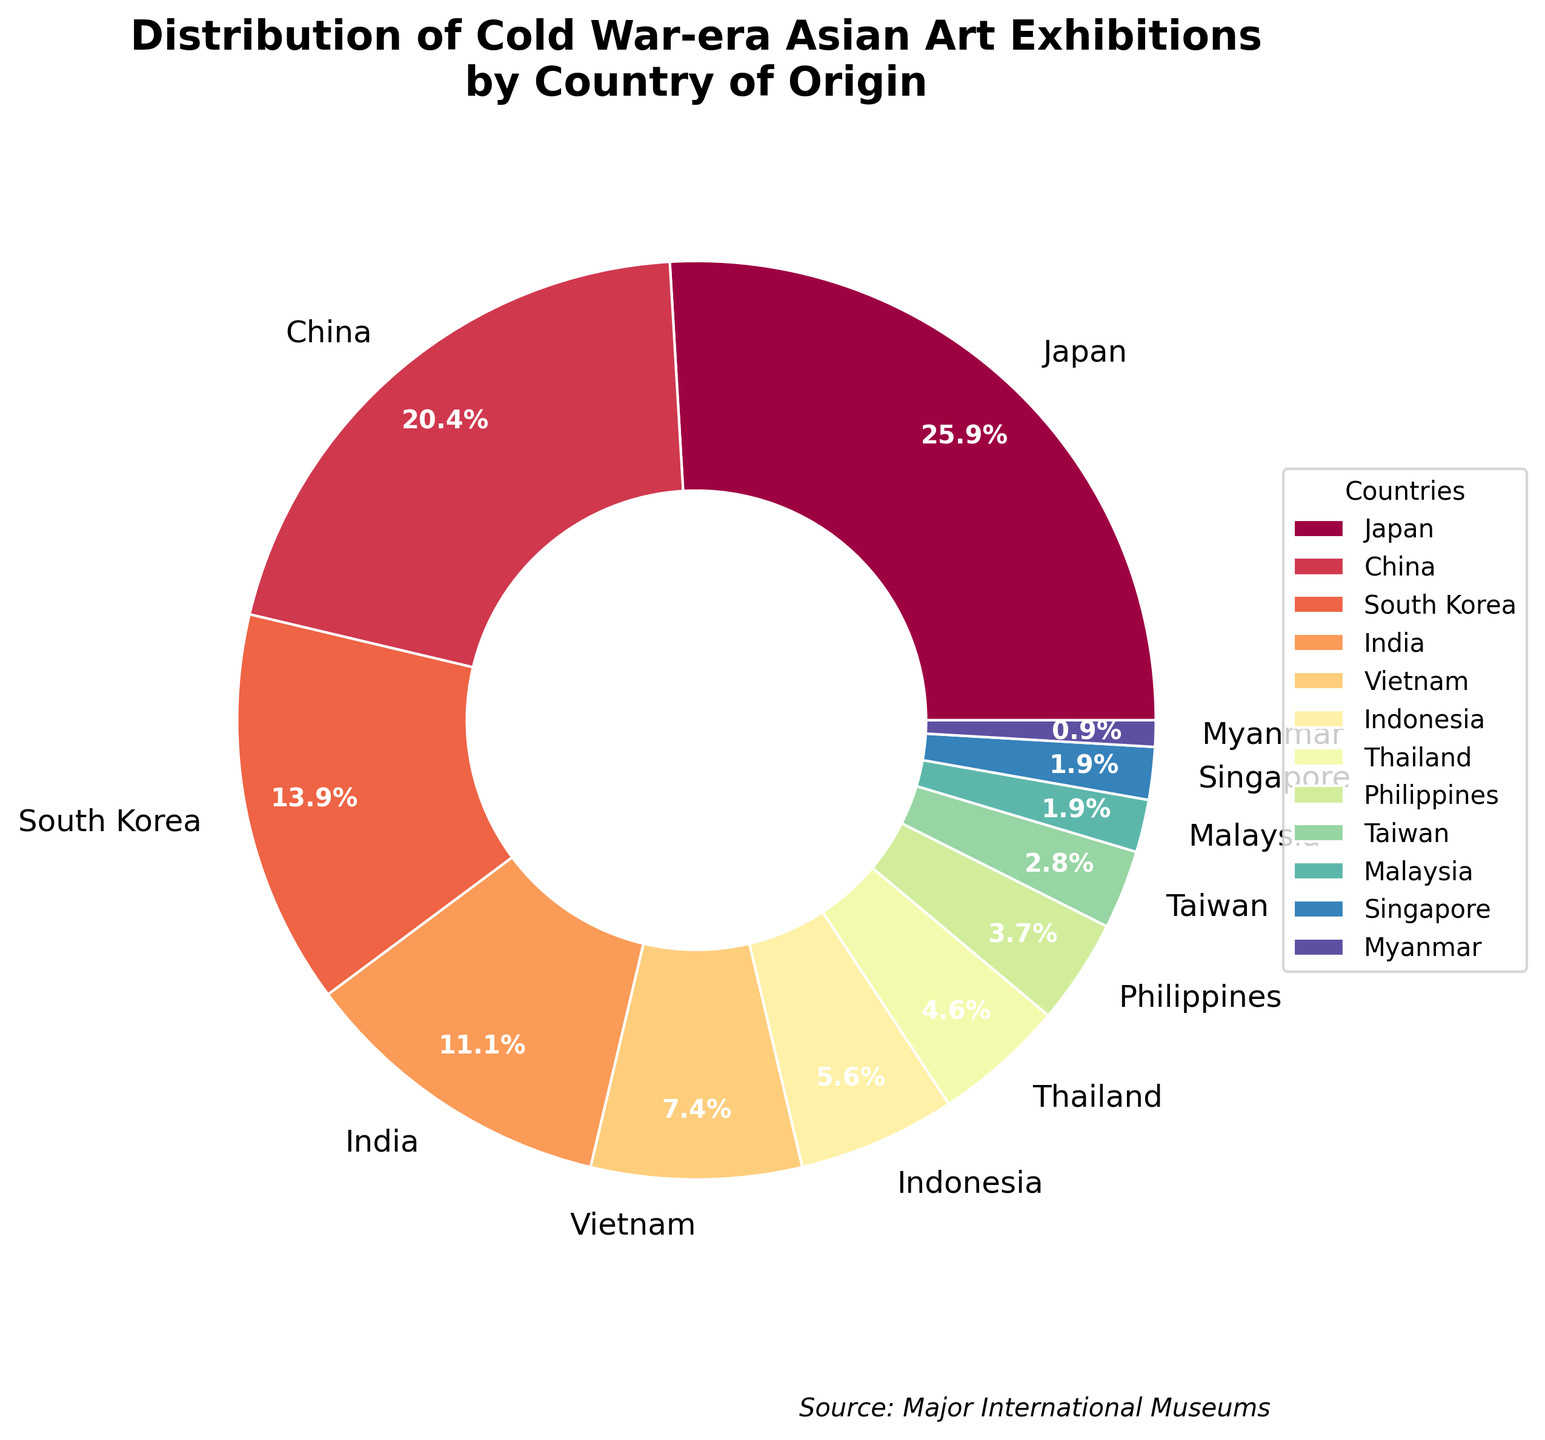What percentage of the exhibitions originated from Japan and China combined? To find the combined percentage for Japan and China, add their individual percentages. Japan has 28% and China has 22%. So, 28% + 22% = 50%.
Answer: 50% Which country has the smallest percentage of exhibitions? By looking at the pie chart, Myanmar has the smallest slice, with 1%.
Answer: Myanmar How does the percentage of exhibitions from South Korea compare to that from India? South Korea has 15%, while India has 12%. To compare, subtract India's percentage from South Korea's percentage. 15% - 12% = 3%.
Answer: South Korea has 3% more What is the total percentage of exhibitions from Indonesia, Vietnam, and Thailand combined? Add the percentages of Indonesia (6%), Vietnam (8%), and Thailand (5%). So, 6% + 8% + 5% = 19%.
Answer: 19% What is the difference in percentage between the countries with the highest and lowest representation? The highest percentage is Japan with 28% and the lowest is Myanmar with 1%. Subtract Myanmar's percentage from Japan's percentage: 28% - 1% = 27%.
Answer: 27% Which countries have less than 5% representation in the exhibitions? According to the chart, the countries with less than 5% are Philippines (4%), Taiwan (3%), Malaysia (2%), Singapore (2%), and Myanmar (1%).
Answer: Philippines, Taiwan, Malaysia, Singapore, Myanmar By how much does the combined percentage of exhibitions from Japan and South Korea exceed that of China and India? First, add the percentages for Japan (28%) and South Korea (15%): 28% + 15% = 43%. Then, add the percentages for China (22%) and India (12%): 22% + 12% = 34%. Finally, subtract the second total from the first: 43% - 34% = 9%.
Answer: 9% Which country accounts for a quarter of the total exhibitions? By looking at the percentages, Japan accounts for 28%, which is closest to a quarter (25%) of the total.
Answer: Japan What is the average percentage of exhibitions from the four countries with the lowest representation? The four countries with the lowest representation are Myanmar (1%), Singapore (2%), Malaysia (2%), and Taiwan (3%). Add their percentages: 1% + 2% + 2% + 3% = 8%. Then, divide by 4 (number of countries): 8% / 4 = 2%.
Answer: 2% How much larger is the percentage of exhibitions from Japan compared to the Philippines? Japan has 28% and the Philippines has 4%. Subtract the Philippines' percentage from Japan's: 28% - 4% = 24%.
Answer: 24% 